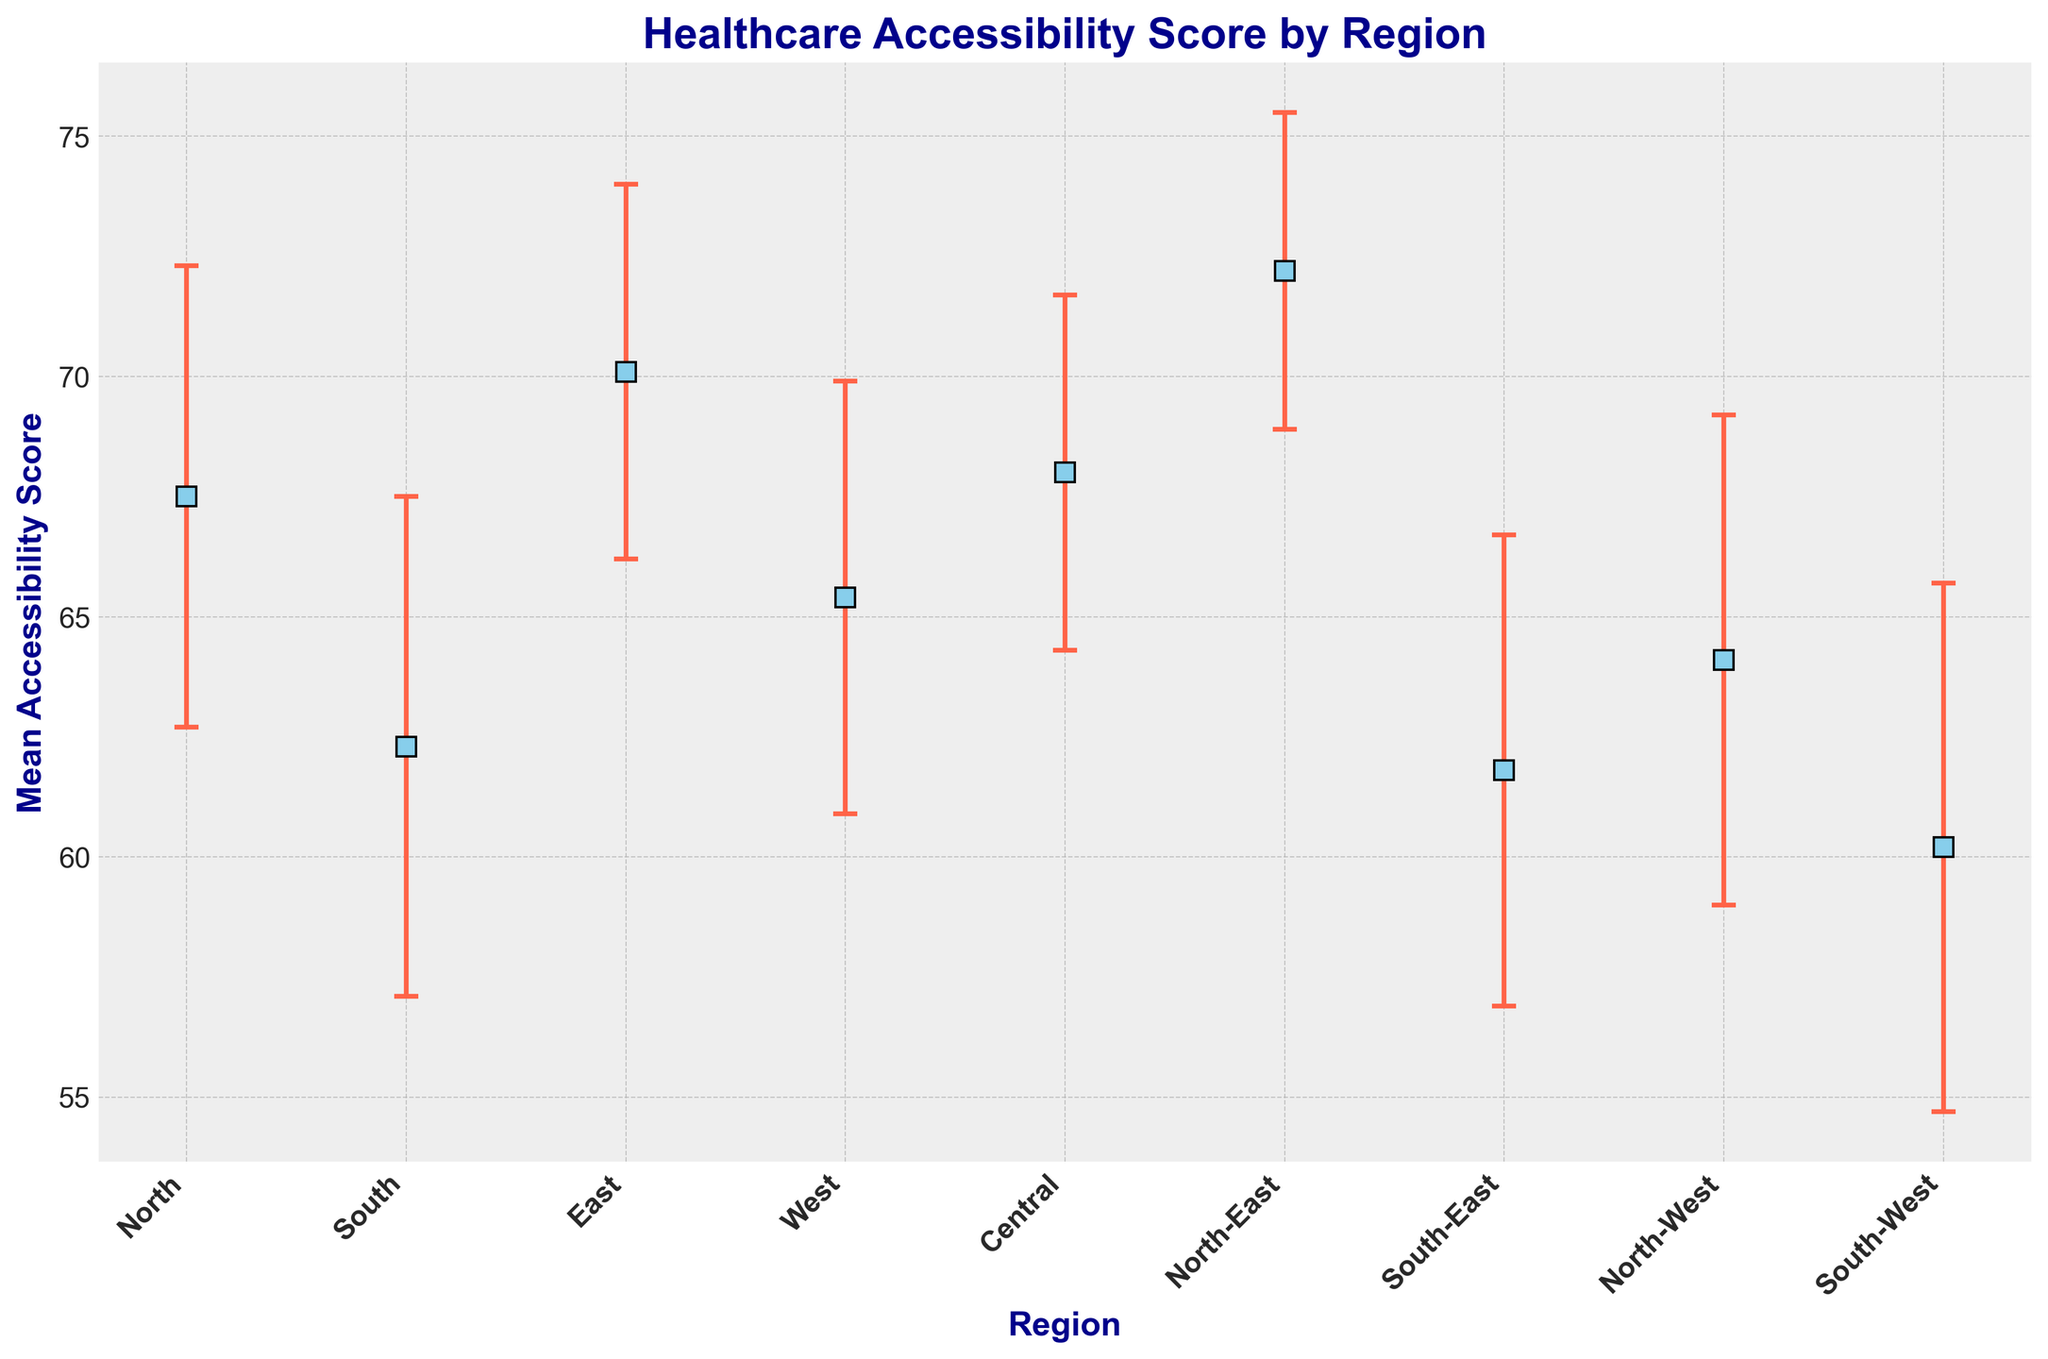Which region has the highest mean accessibility score? The figure shows the mean accessibility scores with error bars for different regions. The North-East region has the highest point on the y-axis.
Answer: North-East Is the mean accessibility score of the South region more than that of the South-West region? By comparing the points on the y-axis for the South and South-West regions, the mean accessibility score of the South region (62.3) is higher than that of the South-West region (60.2).
Answer: Yes What is the difference in mean accessibility scores between the East and the West regions? The mean accessibility score for the East region is 70.1, and for the West region, it is 65.4. The difference between them is 70.1 - 65.4.
Answer: 4.7 Which region has the widest confidence interval? The width of the confidence intervals can be estimated by looking at the length of the error bars on the figure. The South-West region has the longest error bars, suggesting the widest confidence interval.
Answer: South-West Do any regions have overlapping confidence intervals? By visually inspecting the error bars, several regions have overlapping confidence intervals, such as North and Central or South and South-East. This overlap indicates that their accessibility scores are not significantly different.
Answer: Yes What is the range of mean accessibility scores across all regions? The lowest mean accessibility score is for the South-West region (60.2) and the highest is for the North-East region (72.2). The range is 72.2 - 60.2.
Answer: 12.0 Which two regions have the closest mean accessibility scores? By examining the data points, the North and Central regions have mean scores of 67.5 and 68.0, respectively, making them the closest.
Answer: North and Central What is the combined mean accessibility score for the South-East and North-West regions? The mean score for the South-East region is 61.8, and for the North-West region, it is 64.1. Their combined average is (61.8 + 64.1) / 2.
Answer: 62.95 If you were to select a region with below-average healthcare accessibility, which region would you choose? The figure suggests that the below-average regions in terms of mean scores are South-East, South, South-West, and North-West, with the South-West having the lowest score.
Answer: South-West 